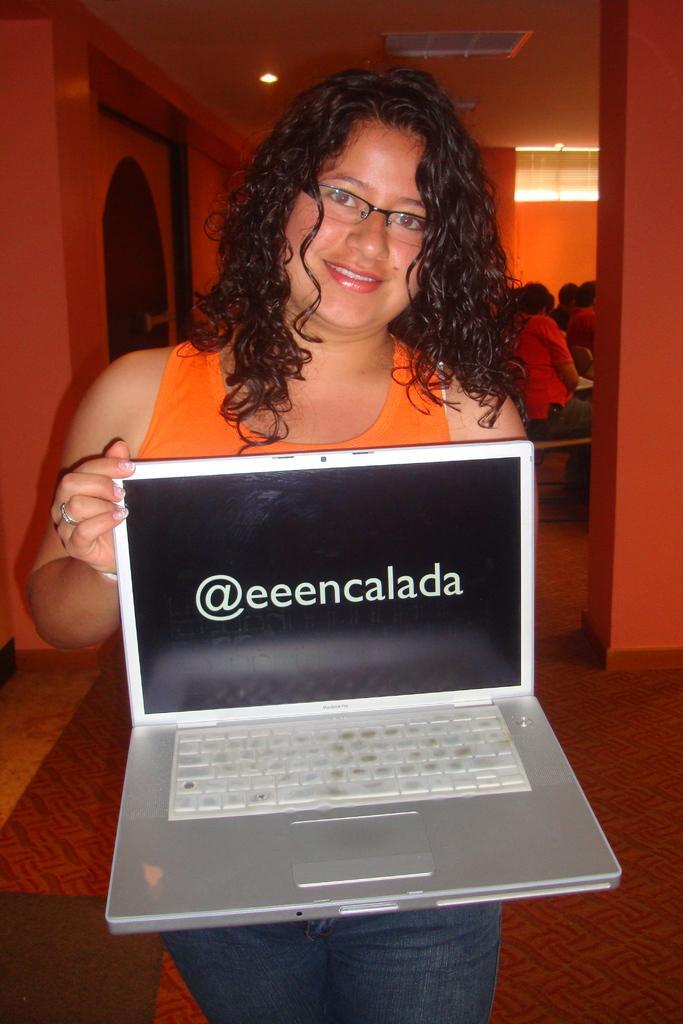Please provide a concise description of this image. In this image in the foreground there is one woman who is standing and she is holding a laptop, and in the background there are some people who are sitting and there are some lights, door and a wall. At the bottom there is a floor. 